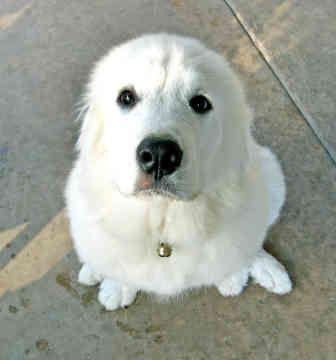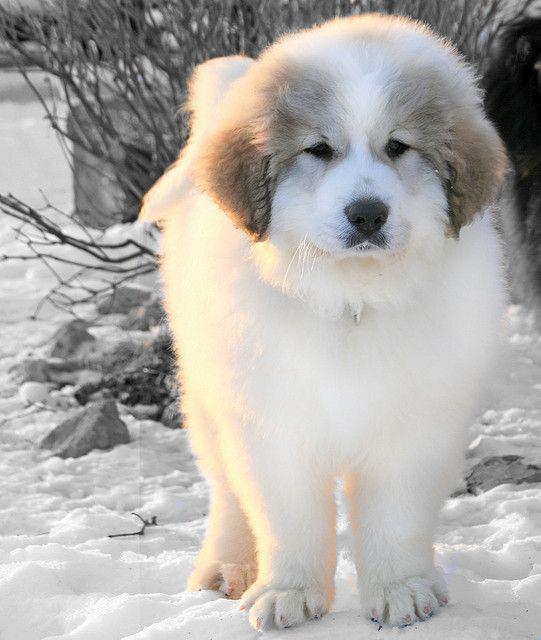The first image is the image on the left, the second image is the image on the right. Examine the images to the left and right. Is the description "The dog in the image on the right is with a human in a vehicle." accurate? Answer yes or no. No. The first image is the image on the left, the second image is the image on the right. Analyze the images presented: Is the assertion "An image includes a person wearing jeans inside a vehicle with one white dog." valid? Answer yes or no. No. 